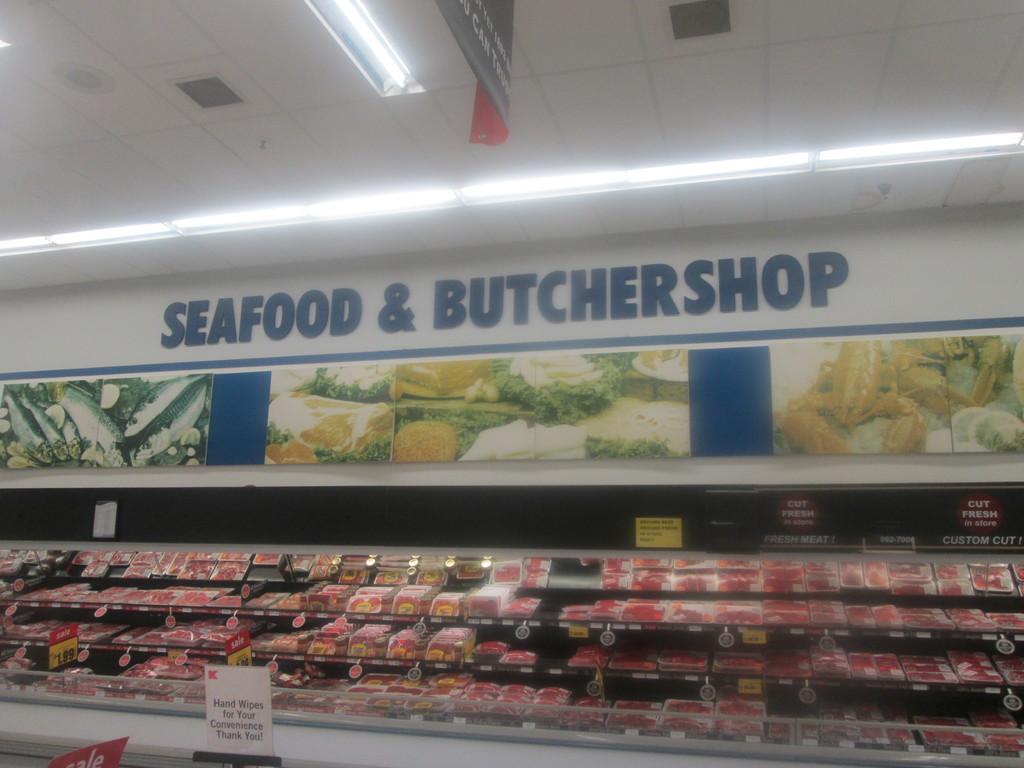What store are they in?
Your answer should be compact. Kmart. What word is following the &?
Offer a very short reply. Butchershop. 